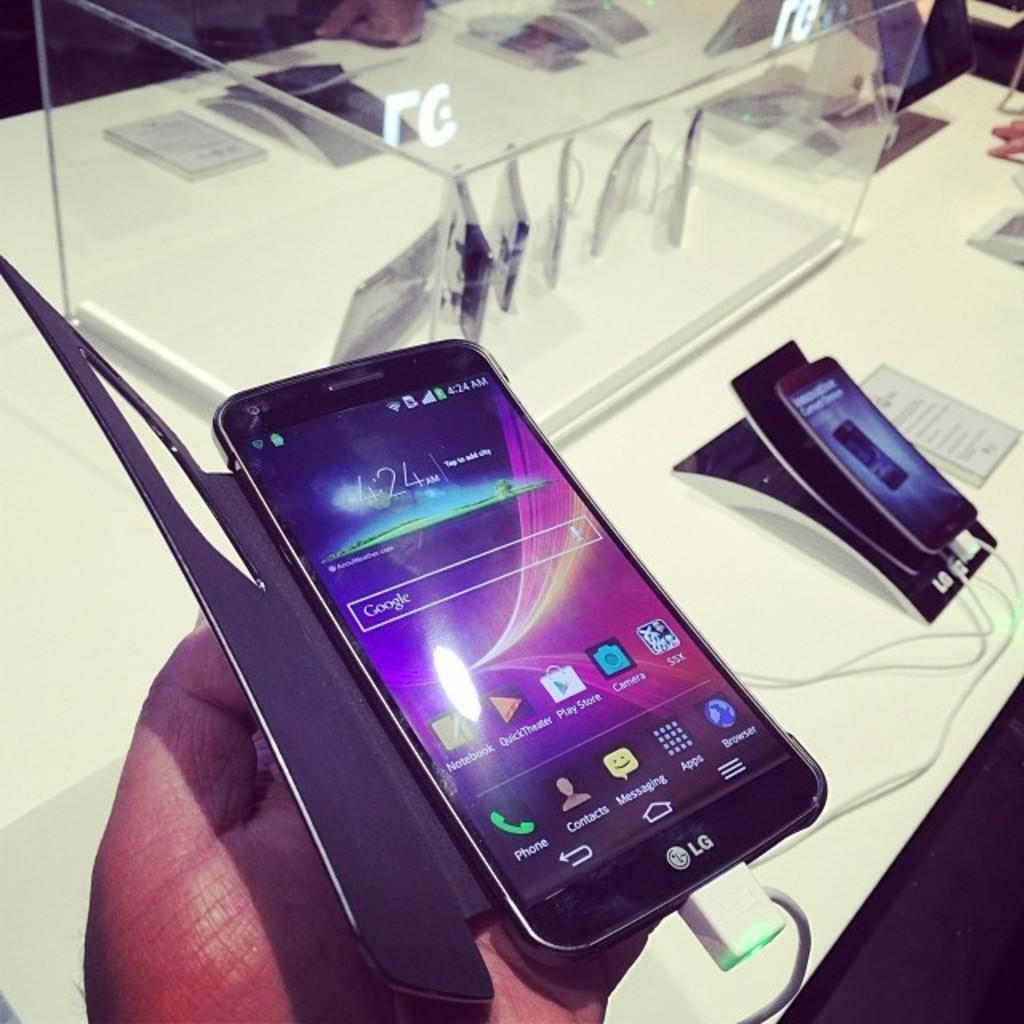<image>
Render a clear and concise summary of the photo. A cell phone set to Google search default is in a person's hand. 